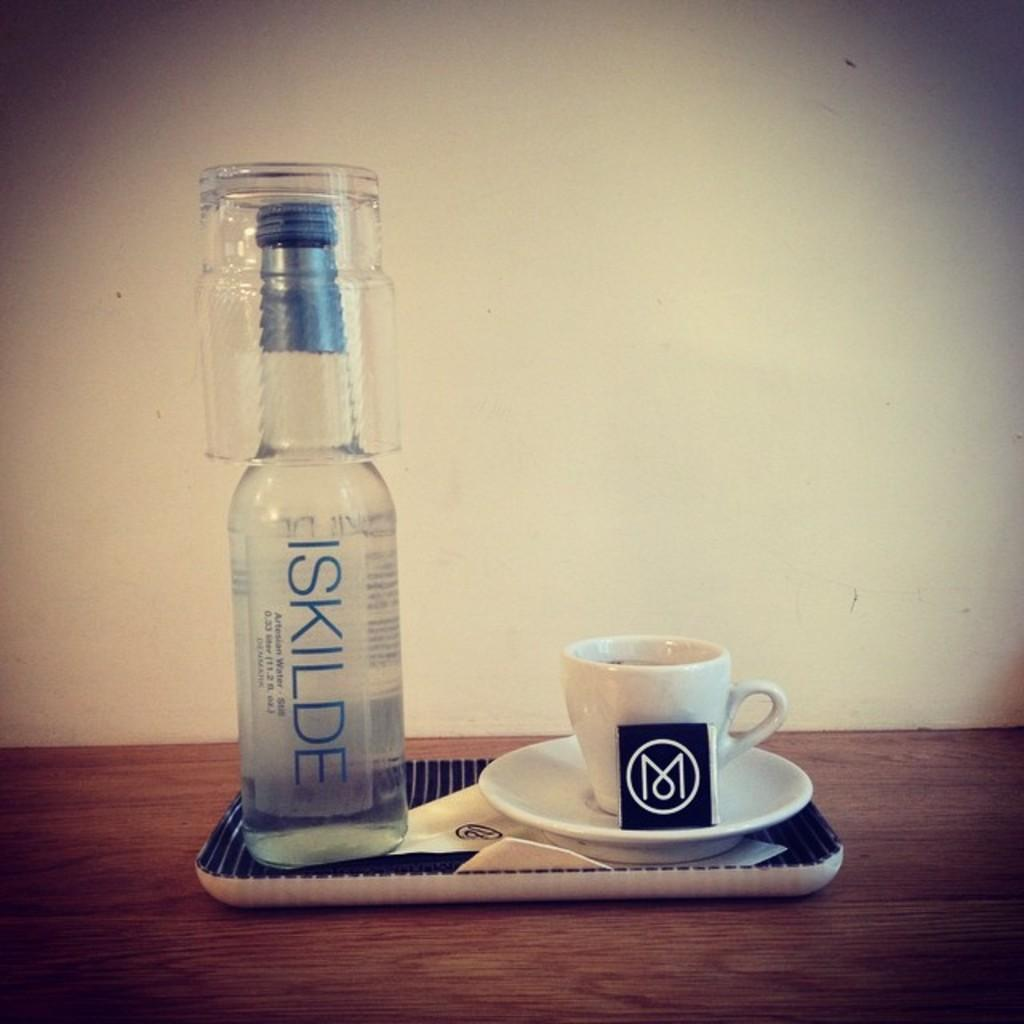<image>
Write a terse but informative summary of the picture. A bottle of Iskilde sits with a shot glass over its lid. 